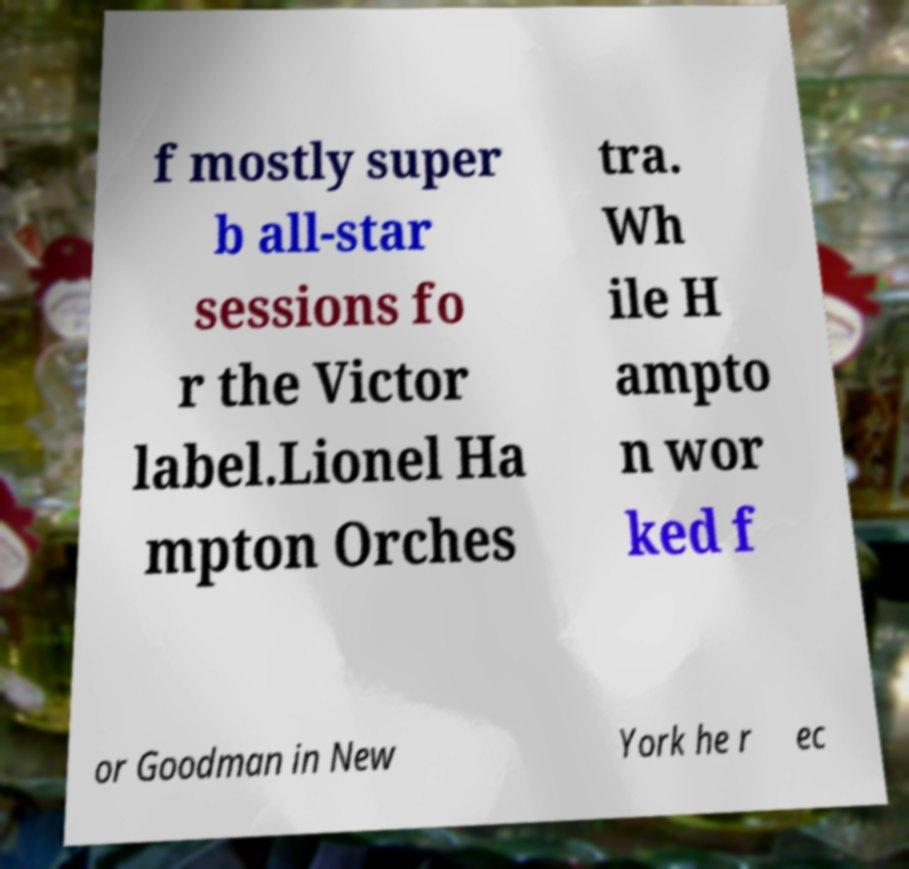Please identify and transcribe the text found in this image. f mostly super b all-star sessions fo r the Victor label.Lionel Ha mpton Orches tra. Wh ile H ampto n wor ked f or Goodman in New York he r ec 